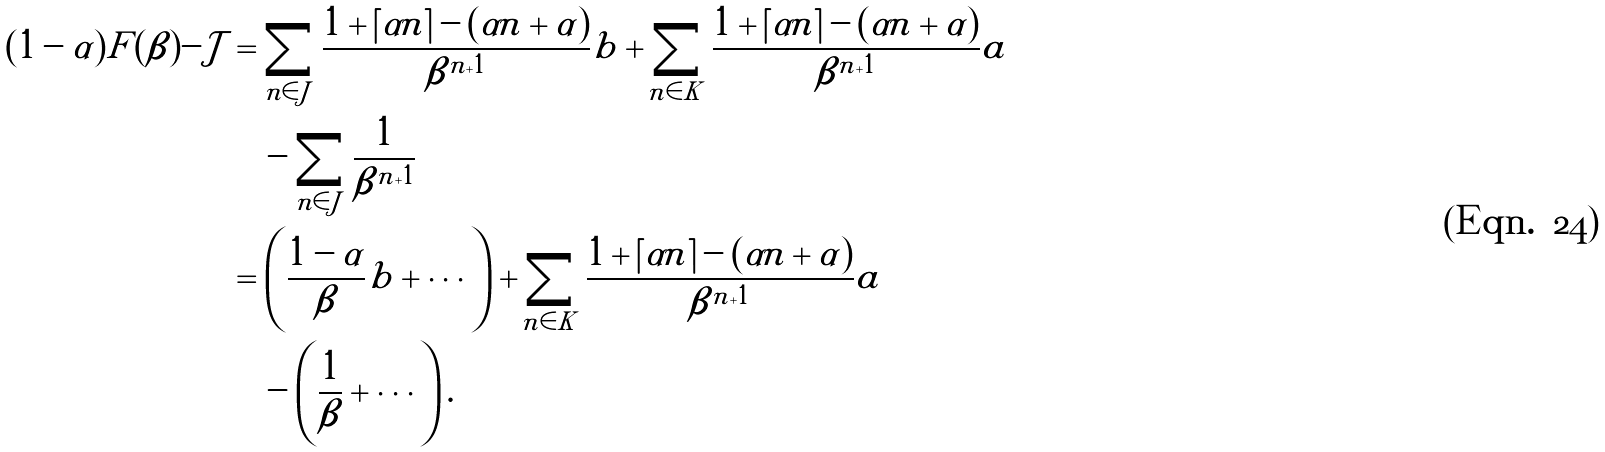Convert formula to latex. <formula><loc_0><loc_0><loc_500><loc_500>( 1 - \alpha ) F ( \beta ) - \mathcal { J } & = \sum _ { n \in J } \frac { 1 + \lceil \alpha n \rceil - ( \alpha n + \alpha ) } { \beta ^ { n + 1 } } b + \sum _ { n \in K } \frac { 1 + \lceil \alpha n \rceil - ( \alpha n + \alpha ) } { \beta ^ { n + 1 } } a \\ & \quad - \sum _ { n \in J } \frac { 1 } { \beta ^ { n + 1 } } \\ & = \left ( \frac { 1 - \alpha } { \beta } b + \cdots \right ) + \sum _ { n \in K } \frac { 1 + \lceil \alpha n \rceil - ( \alpha n + \alpha ) } { \beta ^ { n + 1 } } a \\ & \quad - \left ( \frac { 1 } { \beta } + \cdots \right ) .</formula> 